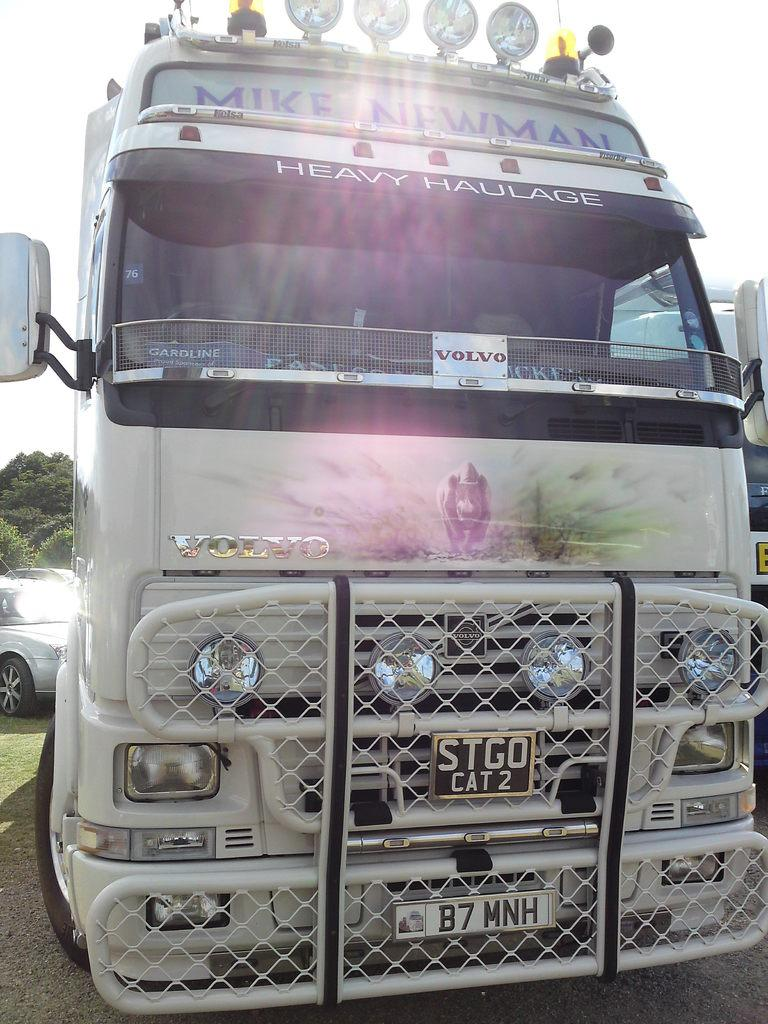<image>
Summarize the visual content of the image. A white truck with the plate STGO cat 2 on the grill of the vehicle. 